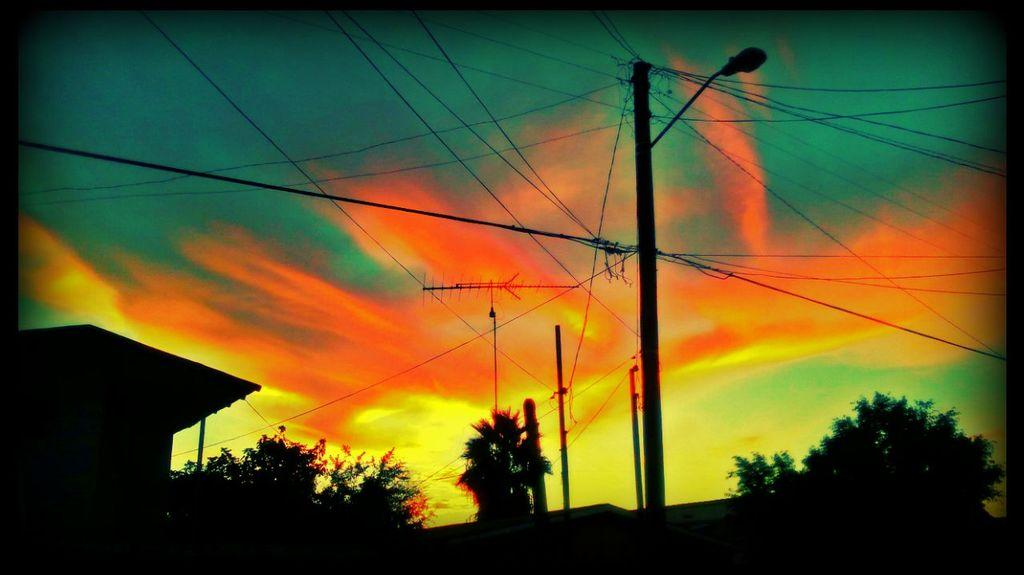What type of structures can be seen in the image? There are electric poles, electric wires, a light pole, and a house in the image. What else is present in the image besides these structures? There are trees in the image. What is visible in the background of the image? The sky is visible in the image. How many quarters can be seen stitched onto the brain in the image? There are no quarters or brains present in the image. 